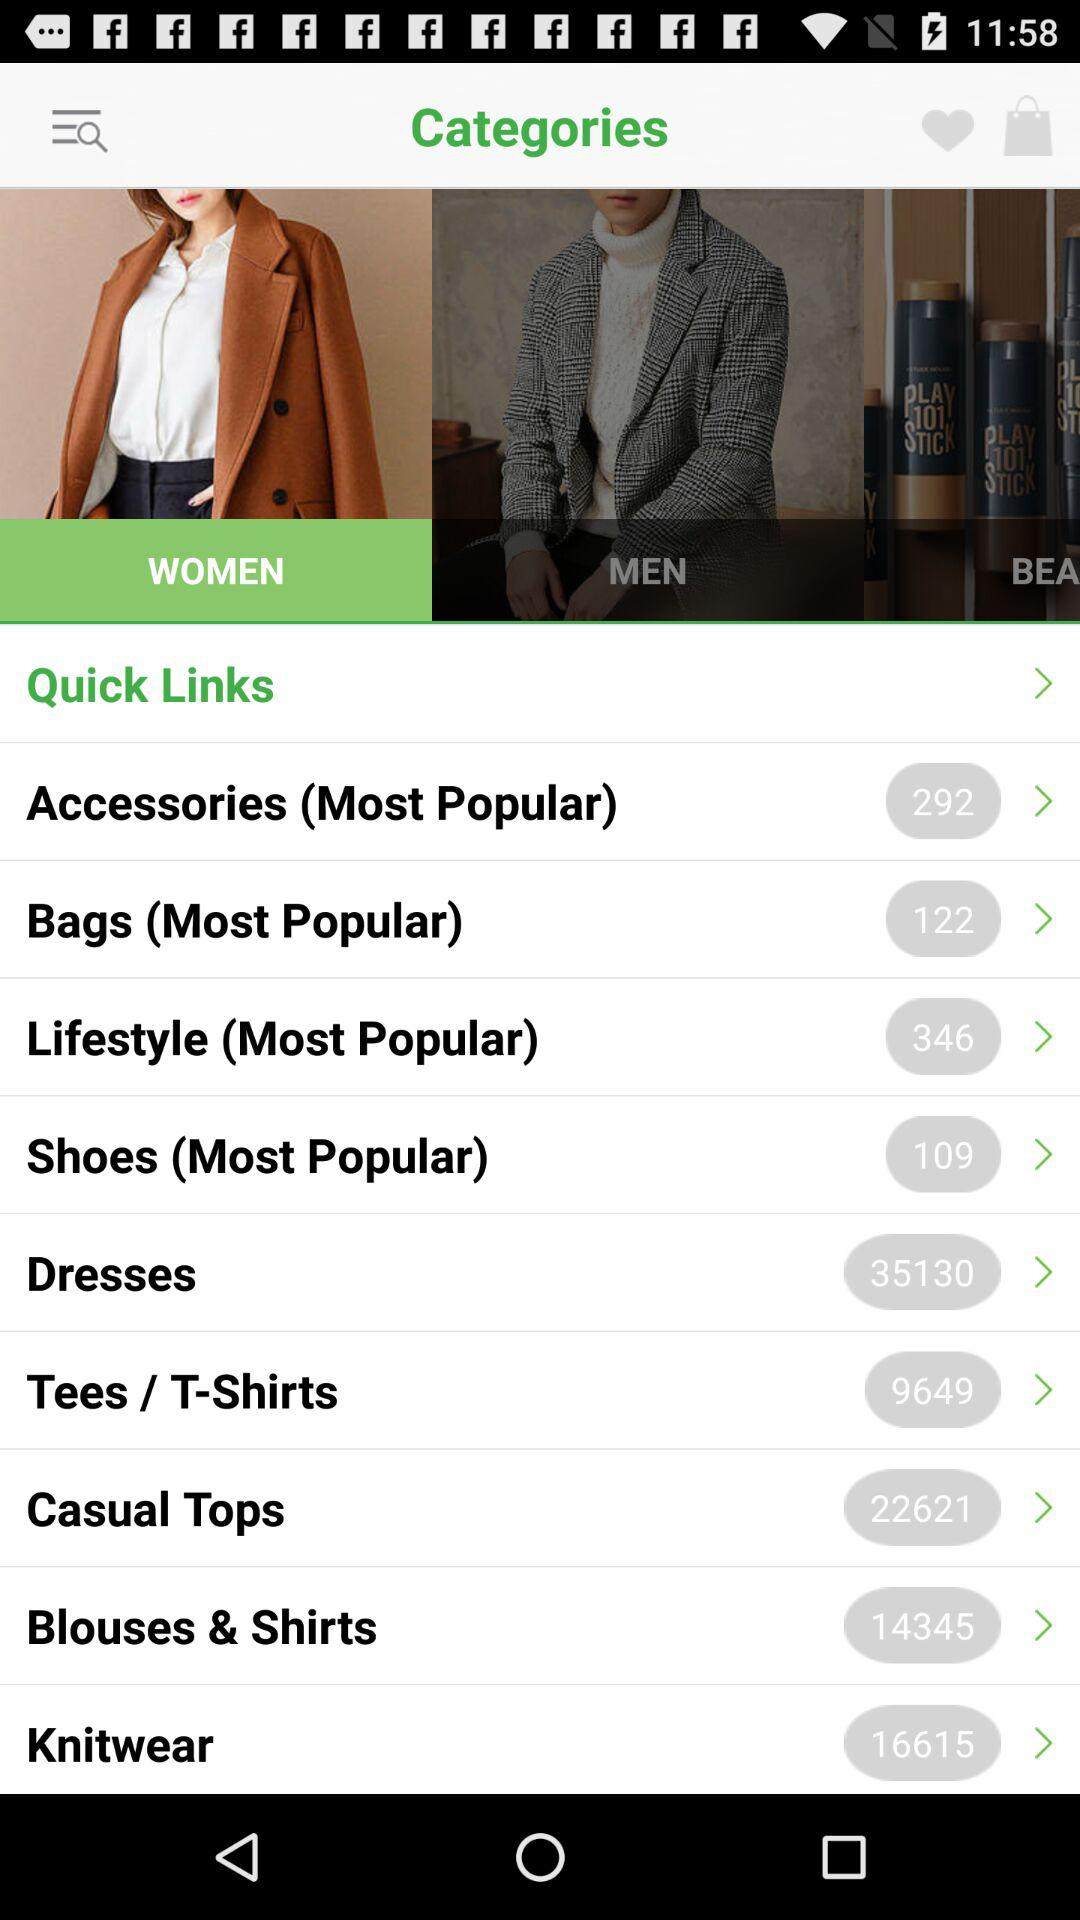How many items are in "Dresses"? There are 35130 items. 